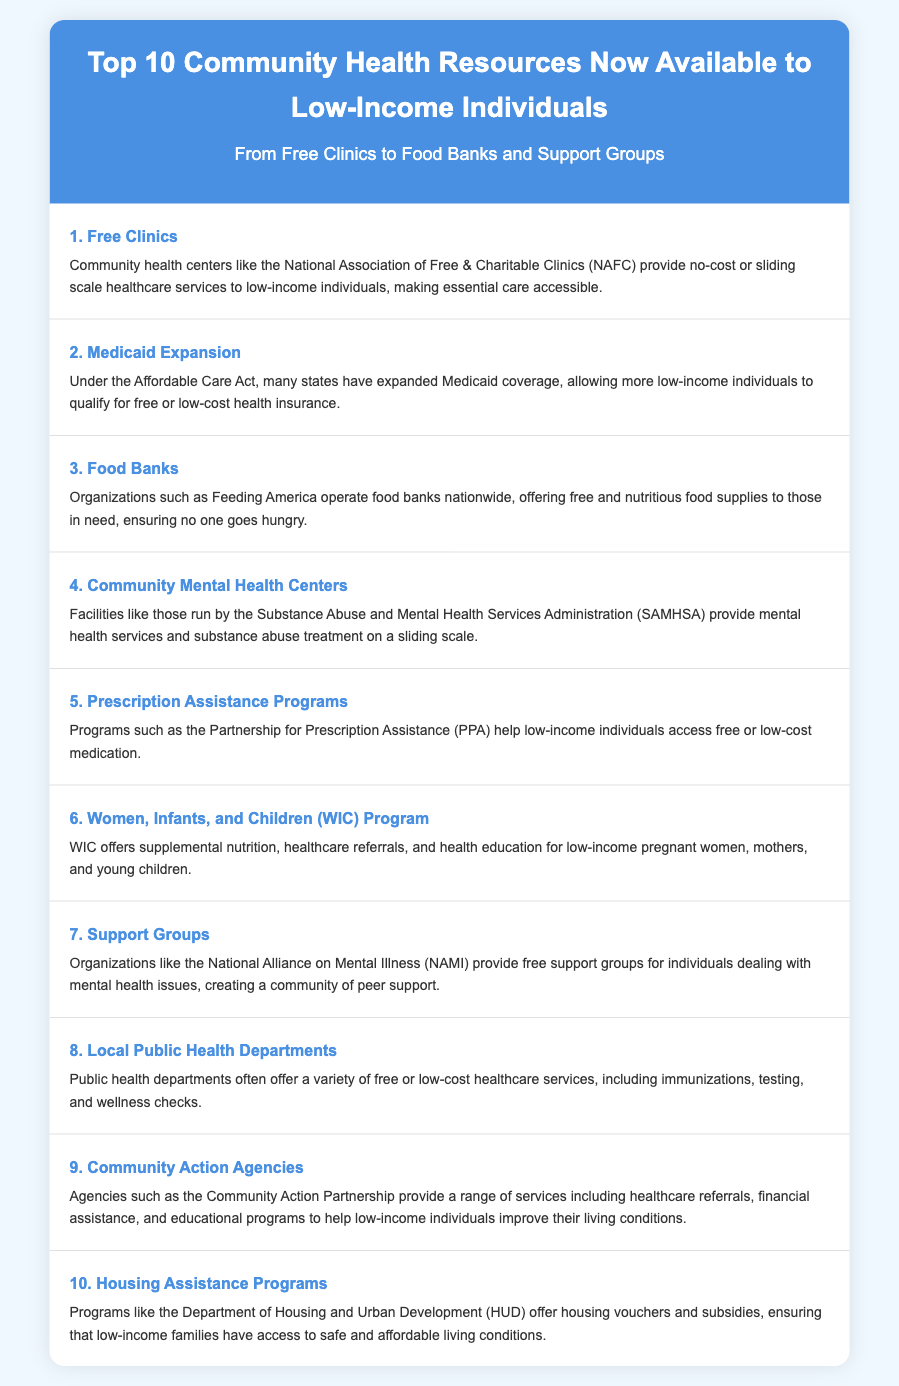What is the first community health resource listed? The document begins with Free Clinics as the first resource available to low-income individuals.
Answer: Free Clinics How many resources are listed in total? The document explicitly lists ten resources available to low-income individuals.
Answer: 10 What does the WIC Program offer? The description of the WIC Program outlines supplemental nutrition, healthcare referrals, and health education.
Answer: Supplemental nutrition Which organization helps access medications? The Partnership for Prescription Assistance (PPA) is identified as the program that helps low-income individuals access medication.
Answer: Partnership for Prescription Assistance What type of assistance do Community Action Agencies provide? The document states that Community Action Agencies provide healthcare referrals and financial assistance among other services.
Answer: Healthcare referrals Which resource is specifically aimed at pregnant women and young children? The WIC Program focuses on low-income pregnant women, mothers, and young children in its services.
Answer: WIC Program How does Medicaid Expansion benefit low-income individuals? The document indicates that Medicaid Expansion allows more low-income individuals to qualify for health insurance coverage.
Answer: Health insurance coverage What organization offers support groups for mental health issues? The National Alliance on Mental Illness (NAMI) is mentioned as providing free support groups.
Answer: National Alliance on Mental Illness Which federal department is associated with housing assistance? The Department of Housing and Urban Development (HUD) is noted in relation to housing assistance programs.
Answer: Department of Housing and Urban Development 